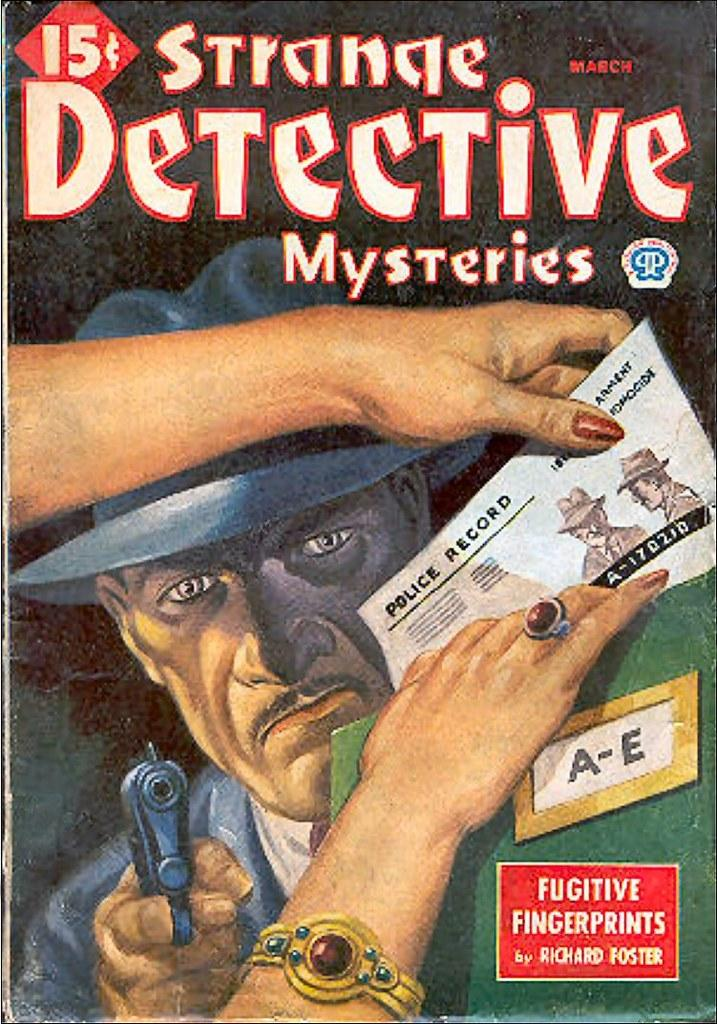<image>
Create a compact narrative representing the image presented. A Strange Detective Mysteries comic book sells for 15 cents for the March issue. 